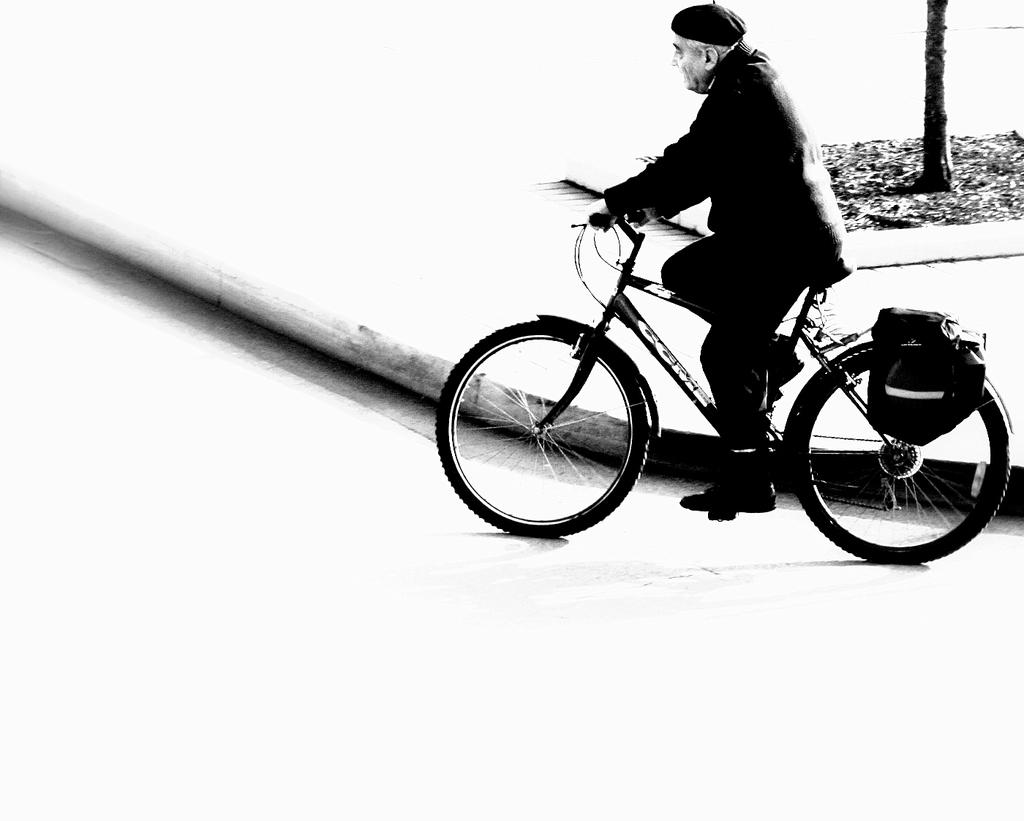Who is the main subject in the image? There is a man in the image. What is the man doing in the image? The man is riding a cycle in the image. What can be seen in the background of the image? There is a tree in the background of the image. What is the distribution of the reaction to the man's point in the image? There is no information about the distribution of reactions or a specific point in the image, as the facts provided only describe the man, his activity, and the background. 